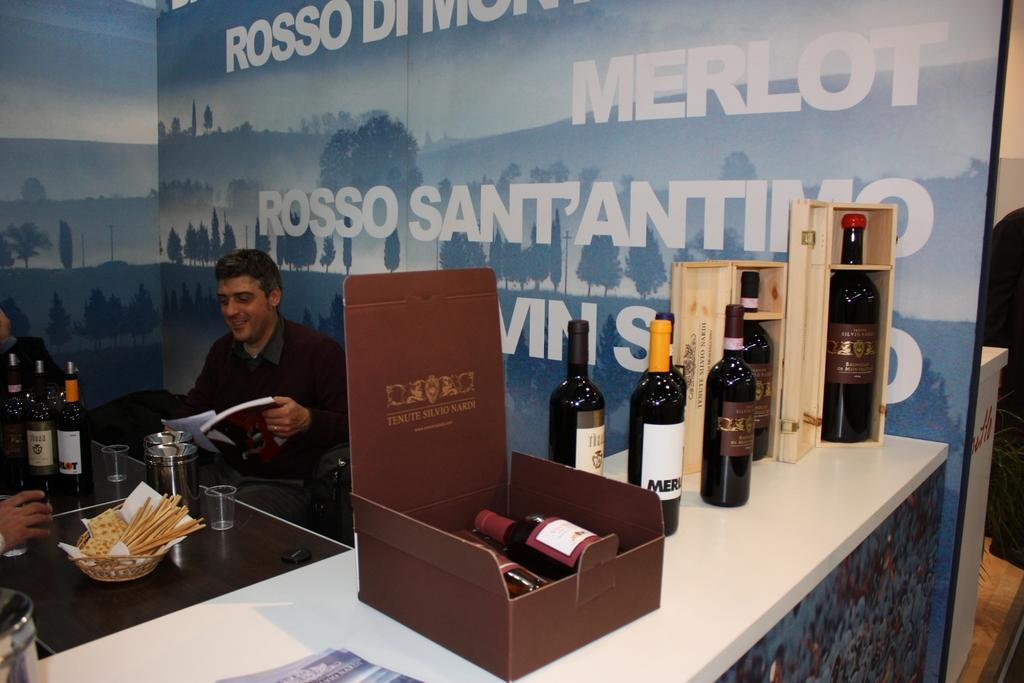<image>
Create a compact narrative representing the image presented. A man at a bar with a box set of Tenute Silvio Nardi among other bottles of wine. 